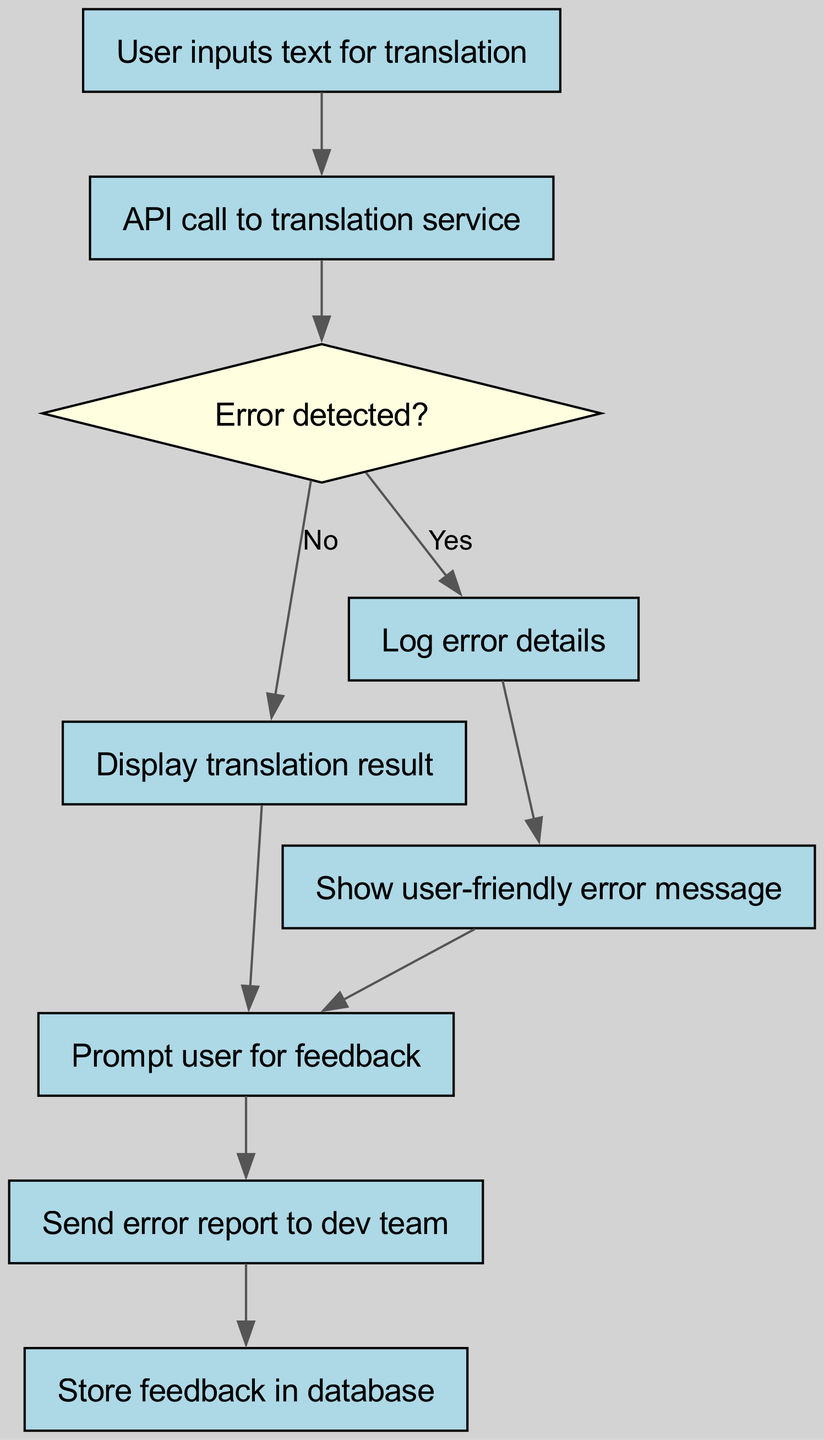What is the first action taken by the user? The first node in the flowchart states "User inputs text for translation," so this is the action initiated by the user.
Answer: User inputs text for translation How many nodes are present in the flowchart? By counting the nodes listed in the data, there are 9 nodes in total, each representing a step in the process.
Answer: 9 What occurs if an error is detected? The flowchart shows that if an error is detected (indicated by a "Yes" from node 3), the process leads to node 5, which is "Log error details."
Answer: Log error details What is displayed if no error is detected during the translation? According to the diagram, if no error is detected ("No" from node 3), the flow proceeds to node 4, which states "Display translation result."
Answer: Display translation result What happens after storing feedback in the database? After the feedback is stored in the database (node 9), there are no subsequent steps indicated in the flowchart, which indicates the process ends there.
Answer: Process ends What type of message is shown to the user when an error occurs? The flowchart specifies that an error results in showing a "Show user-friendly error message" message, which is user-friendly in nature.
Answer: Show user-friendly error message How many connections lead to the feedback collection prompt? The flowchart indicates two connections leading to the "Prompt user for feedback" node: one from "Display translation result" and another from "Show user-friendly error message."
Answer: 2 Which node represents a decision point in the flowchart? The diagram shows that node 3, labeled "Error detected?", is a decision node as it has different pathways depending on the answer.
Answer: Error detected? What action follows the "Show user-friendly error message"? After showing the user-friendly error message (node 6), the flowchart indicates that the next action is prompting the user for feedback (node 7).
Answer: Prompt user for feedback 